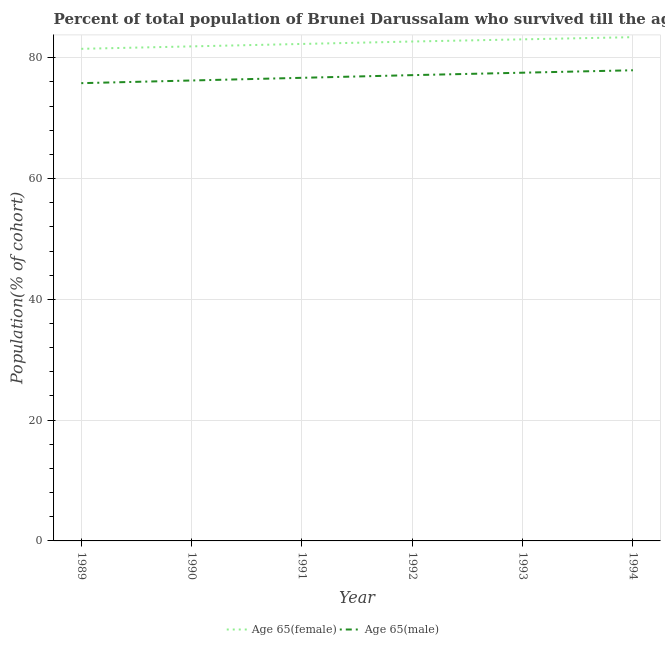How many different coloured lines are there?
Provide a succinct answer. 2. Is the number of lines equal to the number of legend labels?
Provide a short and direct response. Yes. What is the percentage of male population who survived till age of 65 in 1993?
Keep it short and to the point. 77.54. Across all years, what is the maximum percentage of female population who survived till age of 65?
Your answer should be compact. 83.42. Across all years, what is the minimum percentage of male population who survived till age of 65?
Provide a short and direct response. 75.8. What is the total percentage of male population who survived till age of 65 in the graph?
Ensure brevity in your answer.  461.35. What is the difference between the percentage of male population who survived till age of 65 in 1990 and that in 1991?
Your answer should be compact. -0.44. What is the difference between the percentage of female population who survived till age of 65 in 1991 and the percentage of male population who survived till age of 65 in 1992?
Your answer should be very brief. 5.16. What is the average percentage of male population who survived till age of 65 per year?
Keep it short and to the point. 76.89. In the year 1993, what is the difference between the percentage of male population who survived till age of 65 and percentage of female population who survived till age of 65?
Make the answer very short. -5.52. In how many years, is the percentage of male population who survived till age of 65 greater than 44 %?
Your response must be concise. 6. What is the ratio of the percentage of male population who survived till age of 65 in 1990 to that in 1991?
Your response must be concise. 0.99. What is the difference between the highest and the second highest percentage of female population who survived till age of 65?
Ensure brevity in your answer.  0.36. What is the difference between the highest and the lowest percentage of female population who survived till age of 65?
Keep it short and to the point. 1.93. Is the sum of the percentage of female population who survived till age of 65 in 1989 and 1991 greater than the maximum percentage of male population who survived till age of 65 across all years?
Your response must be concise. Yes. Does the percentage of male population who survived till age of 65 monotonically increase over the years?
Provide a succinct answer. Yes. How many lines are there?
Your answer should be compact. 2. How many years are there in the graph?
Provide a succinct answer. 6. Does the graph contain grids?
Your response must be concise. Yes. Where does the legend appear in the graph?
Offer a very short reply. Bottom center. How are the legend labels stacked?
Your answer should be compact. Horizontal. What is the title of the graph?
Give a very brief answer. Percent of total population of Brunei Darussalam who survived till the age of 65 years. Does "Net savings(excluding particulate emission damage)" appear as one of the legend labels in the graph?
Give a very brief answer. No. What is the label or title of the X-axis?
Offer a terse response. Year. What is the label or title of the Y-axis?
Provide a succinct answer. Population(% of cohort). What is the Population(% of cohort) of Age 65(female) in 1989?
Provide a short and direct response. 81.49. What is the Population(% of cohort) in Age 65(male) in 1989?
Your answer should be very brief. 75.8. What is the Population(% of cohort) of Age 65(female) in 1990?
Keep it short and to the point. 81.89. What is the Population(% of cohort) of Age 65(male) in 1990?
Offer a very short reply. 76.25. What is the Population(% of cohort) in Age 65(female) in 1991?
Make the answer very short. 82.3. What is the Population(% of cohort) in Age 65(male) in 1991?
Your answer should be compact. 76.69. What is the Population(% of cohort) in Age 65(female) in 1992?
Make the answer very short. 82.7. What is the Population(% of cohort) in Age 65(male) in 1992?
Provide a succinct answer. 77.13. What is the Population(% of cohort) in Age 65(female) in 1993?
Provide a short and direct response. 83.06. What is the Population(% of cohort) of Age 65(male) in 1993?
Provide a short and direct response. 77.54. What is the Population(% of cohort) of Age 65(female) in 1994?
Provide a short and direct response. 83.42. What is the Population(% of cohort) of Age 65(male) in 1994?
Make the answer very short. 77.94. Across all years, what is the maximum Population(% of cohort) in Age 65(female)?
Offer a very short reply. 83.42. Across all years, what is the maximum Population(% of cohort) in Age 65(male)?
Ensure brevity in your answer.  77.94. Across all years, what is the minimum Population(% of cohort) of Age 65(female)?
Offer a terse response. 81.49. Across all years, what is the minimum Population(% of cohort) in Age 65(male)?
Make the answer very short. 75.8. What is the total Population(% of cohort) in Age 65(female) in the graph?
Provide a succinct answer. 494.86. What is the total Population(% of cohort) in Age 65(male) in the graph?
Provide a short and direct response. 461.35. What is the difference between the Population(% of cohort) of Age 65(female) in 1989 and that in 1990?
Offer a terse response. -0.4. What is the difference between the Population(% of cohort) of Age 65(male) in 1989 and that in 1990?
Provide a short and direct response. -0.44. What is the difference between the Population(% of cohort) in Age 65(female) in 1989 and that in 1991?
Provide a succinct answer. -0.81. What is the difference between the Population(% of cohort) of Age 65(male) in 1989 and that in 1991?
Your response must be concise. -0.89. What is the difference between the Population(% of cohort) in Age 65(female) in 1989 and that in 1992?
Provide a succinct answer. -1.21. What is the difference between the Population(% of cohort) in Age 65(male) in 1989 and that in 1992?
Give a very brief answer. -1.33. What is the difference between the Population(% of cohort) of Age 65(female) in 1989 and that in 1993?
Your response must be concise. -1.57. What is the difference between the Population(% of cohort) of Age 65(male) in 1989 and that in 1993?
Keep it short and to the point. -1.73. What is the difference between the Population(% of cohort) in Age 65(female) in 1989 and that in 1994?
Give a very brief answer. -1.93. What is the difference between the Population(% of cohort) in Age 65(male) in 1989 and that in 1994?
Give a very brief answer. -2.14. What is the difference between the Population(% of cohort) of Age 65(female) in 1990 and that in 1991?
Your answer should be very brief. -0.4. What is the difference between the Population(% of cohort) in Age 65(male) in 1990 and that in 1991?
Offer a very short reply. -0.44. What is the difference between the Population(% of cohort) in Age 65(female) in 1990 and that in 1992?
Your answer should be very brief. -0.81. What is the difference between the Population(% of cohort) of Age 65(male) in 1990 and that in 1992?
Make the answer very short. -0.89. What is the difference between the Population(% of cohort) in Age 65(female) in 1990 and that in 1993?
Keep it short and to the point. -1.17. What is the difference between the Population(% of cohort) in Age 65(male) in 1990 and that in 1993?
Your answer should be compact. -1.29. What is the difference between the Population(% of cohort) in Age 65(female) in 1990 and that in 1994?
Your answer should be very brief. -1.52. What is the difference between the Population(% of cohort) of Age 65(male) in 1990 and that in 1994?
Your response must be concise. -1.69. What is the difference between the Population(% of cohort) in Age 65(female) in 1991 and that in 1992?
Offer a terse response. -0.4. What is the difference between the Population(% of cohort) in Age 65(male) in 1991 and that in 1992?
Make the answer very short. -0.44. What is the difference between the Population(% of cohort) of Age 65(female) in 1991 and that in 1993?
Offer a terse response. -0.76. What is the difference between the Population(% of cohort) in Age 65(male) in 1991 and that in 1993?
Make the answer very short. -0.85. What is the difference between the Population(% of cohort) in Age 65(female) in 1991 and that in 1994?
Keep it short and to the point. -1.12. What is the difference between the Population(% of cohort) of Age 65(male) in 1991 and that in 1994?
Give a very brief answer. -1.25. What is the difference between the Population(% of cohort) in Age 65(female) in 1992 and that in 1993?
Provide a short and direct response. -0.36. What is the difference between the Population(% of cohort) in Age 65(male) in 1992 and that in 1993?
Provide a short and direct response. -0.4. What is the difference between the Population(% of cohort) of Age 65(female) in 1992 and that in 1994?
Your answer should be compact. -0.72. What is the difference between the Population(% of cohort) in Age 65(male) in 1992 and that in 1994?
Give a very brief answer. -0.81. What is the difference between the Population(% of cohort) in Age 65(female) in 1993 and that in 1994?
Offer a very short reply. -0.36. What is the difference between the Population(% of cohort) in Age 65(male) in 1993 and that in 1994?
Your response must be concise. -0.4. What is the difference between the Population(% of cohort) of Age 65(female) in 1989 and the Population(% of cohort) of Age 65(male) in 1990?
Offer a very short reply. 5.24. What is the difference between the Population(% of cohort) in Age 65(female) in 1989 and the Population(% of cohort) in Age 65(male) in 1991?
Your answer should be compact. 4.8. What is the difference between the Population(% of cohort) of Age 65(female) in 1989 and the Population(% of cohort) of Age 65(male) in 1992?
Offer a terse response. 4.36. What is the difference between the Population(% of cohort) of Age 65(female) in 1989 and the Population(% of cohort) of Age 65(male) in 1993?
Provide a succinct answer. 3.96. What is the difference between the Population(% of cohort) of Age 65(female) in 1989 and the Population(% of cohort) of Age 65(male) in 1994?
Provide a short and direct response. 3.55. What is the difference between the Population(% of cohort) in Age 65(female) in 1990 and the Population(% of cohort) in Age 65(male) in 1991?
Give a very brief answer. 5.2. What is the difference between the Population(% of cohort) of Age 65(female) in 1990 and the Population(% of cohort) of Age 65(male) in 1992?
Provide a short and direct response. 4.76. What is the difference between the Population(% of cohort) of Age 65(female) in 1990 and the Population(% of cohort) of Age 65(male) in 1993?
Give a very brief answer. 4.36. What is the difference between the Population(% of cohort) in Age 65(female) in 1990 and the Population(% of cohort) in Age 65(male) in 1994?
Offer a terse response. 3.96. What is the difference between the Population(% of cohort) of Age 65(female) in 1991 and the Population(% of cohort) of Age 65(male) in 1992?
Your answer should be very brief. 5.16. What is the difference between the Population(% of cohort) in Age 65(female) in 1991 and the Population(% of cohort) in Age 65(male) in 1993?
Give a very brief answer. 4.76. What is the difference between the Population(% of cohort) in Age 65(female) in 1991 and the Population(% of cohort) in Age 65(male) in 1994?
Provide a short and direct response. 4.36. What is the difference between the Population(% of cohort) in Age 65(female) in 1992 and the Population(% of cohort) in Age 65(male) in 1993?
Your answer should be compact. 5.16. What is the difference between the Population(% of cohort) in Age 65(female) in 1992 and the Population(% of cohort) in Age 65(male) in 1994?
Keep it short and to the point. 4.76. What is the difference between the Population(% of cohort) of Age 65(female) in 1993 and the Population(% of cohort) of Age 65(male) in 1994?
Offer a very short reply. 5.12. What is the average Population(% of cohort) of Age 65(female) per year?
Your response must be concise. 82.48. What is the average Population(% of cohort) in Age 65(male) per year?
Provide a succinct answer. 76.89. In the year 1989, what is the difference between the Population(% of cohort) of Age 65(female) and Population(% of cohort) of Age 65(male)?
Your answer should be very brief. 5.69. In the year 1990, what is the difference between the Population(% of cohort) in Age 65(female) and Population(% of cohort) in Age 65(male)?
Make the answer very short. 5.65. In the year 1991, what is the difference between the Population(% of cohort) in Age 65(female) and Population(% of cohort) in Age 65(male)?
Ensure brevity in your answer.  5.61. In the year 1992, what is the difference between the Population(% of cohort) of Age 65(female) and Population(% of cohort) of Age 65(male)?
Keep it short and to the point. 5.57. In the year 1993, what is the difference between the Population(% of cohort) of Age 65(female) and Population(% of cohort) of Age 65(male)?
Offer a terse response. 5.52. In the year 1994, what is the difference between the Population(% of cohort) of Age 65(female) and Population(% of cohort) of Age 65(male)?
Make the answer very short. 5.48. What is the ratio of the Population(% of cohort) of Age 65(male) in 1989 to that in 1990?
Your response must be concise. 0.99. What is the ratio of the Population(% of cohort) in Age 65(female) in 1989 to that in 1991?
Keep it short and to the point. 0.99. What is the ratio of the Population(% of cohort) of Age 65(male) in 1989 to that in 1991?
Keep it short and to the point. 0.99. What is the ratio of the Population(% of cohort) in Age 65(female) in 1989 to that in 1992?
Offer a terse response. 0.99. What is the ratio of the Population(% of cohort) of Age 65(male) in 1989 to that in 1992?
Keep it short and to the point. 0.98. What is the ratio of the Population(% of cohort) of Age 65(female) in 1989 to that in 1993?
Offer a very short reply. 0.98. What is the ratio of the Population(% of cohort) of Age 65(male) in 1989 to that in 1993?
Provide a succinct answer. 0.98. What is the ratio of the Population(% of cohort) in Age 65(female) in 1989 to that in 1994?
Keep it short and to the point. 0.98. What is the ratio of the Population(% of cohort) of Age 65(male) in 1989 to that in 1994?
Ensure brevity in your answer.  0.97. What is the ratio of the Population(% of cohort) of Age 65(female) in 1990 to that in 1991?
Your response must be concise. 1. What is the ratio of the Population(% of cohort) in Age 65(female) in 1990 to that in 1992?
Offer a terse response. 0.99. What is the ratio of the Population(% of cohort) of Age 65(male) in 1990 to that in 1993?
Your answer should be very brief. 0.98. What is the ratio of the Population(% of cohort) of Age 65(female) in 1990 to that in 1994?
Your answer should be compact. 0.98. What is the ratio of the Population(% of cohort) in Age 65(male) in 1990 to that in 1994?
Offer a terse response. 0.98. What is the ratio of the Population(% of cohort) of Age 65(female) in 1991 to that in 1992?
Offer a terse response. 1. What is the ratio of the Population(% of cohort) of Age 65(male) in 1991 to that in 1993?
Make the answer very short. 0.99. What is the ratio of the Population(% of cohort) of Age 65(female) in 1991 to that in 1994?
Keep it short and to the point. 0.99. What is the ratio of the Population(% of cohort) in Age 65(female) in 1992 to that in 1993?
Keep it short and to the point. 1. What is the ratio of the Population(% of cohort) of Age 65(male) in 1993 to that in 1994?
Offer a terse response. 0.99. What is the difference between the highest and the second highest Population(% of cohort) in Age 65(female)?
Keep it short and to the point. 0.36. What is the difference between the highest and the second highest Population(% of cohort) in Age 65(male)?
Your answer should be compact. 0.4. What is the difference between the highest and the lowest Population(% of cohort) in Age 65(female)?
Your response must be concise. 1.93. What is the difference between the highest and the lowest Population(% of cohort) of Age 65(male)?
Ensure brevity in your answer.  2.14. 